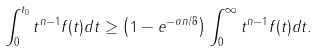Convert formula to latex. <formula><loc_0><loc_0><loc_500><loc_500>\int _ { 0 } ^ { t _ { 0 } } t ^ { n - 1 } f ( t ) d t \geq \left ( 1 - e ^ { - \alpha n / 8 } \right ) \int _ { 0 } ^ { \infty } t ^ { n - 1 } f ( t ) d t .</formula> 